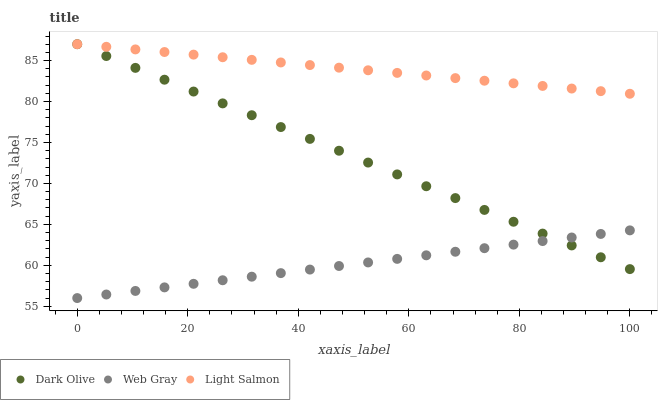Does Web Gray have the minimum area under the curve?
Answer yes or no. Yes. Does Light Salmon have the maximum area under the curve?
Answer yes or no. Yes. Does Dark Olive have the minimum area under the curve?
Answer yes or no. No. Does Dark Olive have the maximum area under the curve?
Answer yes or no. No. Is Web Gray the smoothest?
Answer yes or no. Yes. Is Dark Olive the roughest?
Answer yes or no. Yes. Is Dark Olive the smoothest?
Answer yes or no. No. Is Web Gray the roughest?
Answer yes or no. No. Does Web Gray have the lowest value?
Answer yes or no. Yes. Does Dark Olive have the lowest value?
Answer yes or no. No. Does Dark Olive have the highest value?
Answer yes or no. Yes. Does Web Gray have the highest value?
Answer yes or no. No. Is Web Gray less than Light Salmon?
Answer yes or no. Yes. Is Light Salmon greater than Web Gray?
Answer yes or no. Yes. Does Dark Olive intersect Web Gray?
Answer yes or no. Yes. Is Dark Olive less than Web Gray?
Answer yes or no. No. Is Dark Olive greater than Web Gray?
Answer yes or no. No. Does Web Gray intersect Light Salmon?
Answer yes or no. No. 